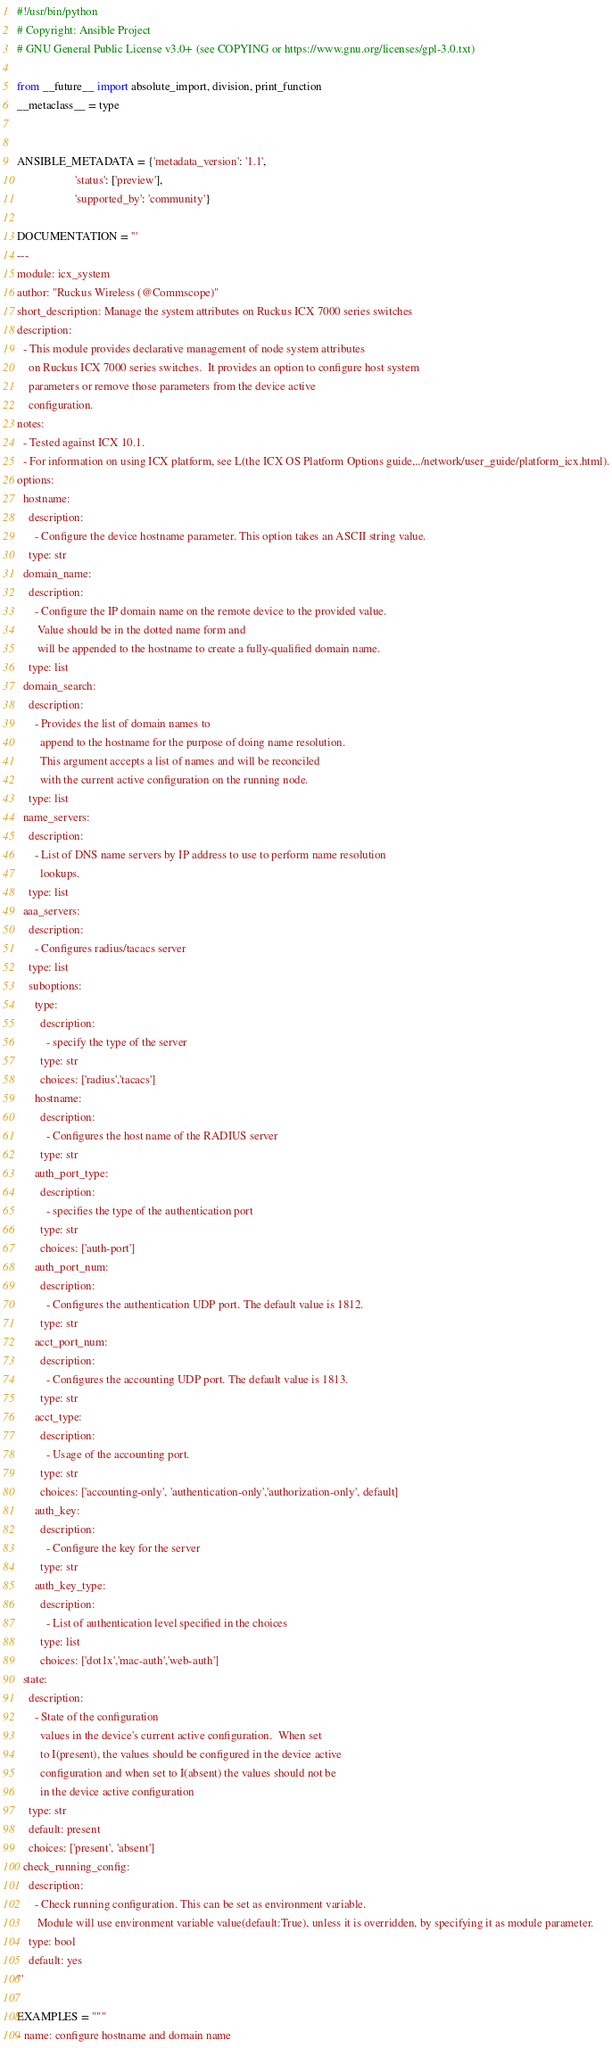Convert code to text. <code><loc_0><loc_0><loc_500><loc_500><_Python_>#!/usr/bin/python
# Copyright: Ansible Project
# GNU General Public License v3.0+ (see COPYING or https://www.gnu.org/licenses/gpl-3.0.txt)

from __future__ import absolute_import, division, print_function
__metaclass__ = type


ANSIBLE_METADATA = {'metadata_version': '1.1',
                    'status': ['preview'],
                    'supported_by': 'community'}

DOCUMENTATION = '''
---
module: icx_system
author: "Ruckus Wireless (@Commscope)"
short_description: Manage the system attributes on Ruckus ICX 7000 series switches
description:
  - This module provides declarative management of node system attributes
    on Ruckus ICX 7000 series switches.  It provides an option to configure host system
    parameters or remove those parameters from the device active
    configuration.
notes:
  - Tested against ICX 10.1.
  - For information on using ICX platform, see L(the ICX OS Platform Options guide,../network/user_guide/platform_icx.html).
options:
  hostname:
    description:
      - Configure the device hostname parameter. This option takes an ASCII string value.
    type: str
  domain_name:
    description:
      - Configure the IP domain name on the remote device to the provided value.
       Value should be in the dotted name form and
       will be appended to the hostname to create a fully-qualified domain name.
    type: list
  domain_search:
    description:
      - Provides the list of domain names to
        append to the hostname for the purpose of doing name resolution.
        This argument accepts a list of names and will be reconciled
        with the current active configuration on the running node.
    type: list
  name_servers:
    description:
      - List of DNS name servers by IP address to use to perform name resolution
        lookups.
    type: list
  aaa_servers:
    description:
      - Configures radius/tacacs server
    type: list
    suboptions:
      type:
        description:
          - specify the type of the server
        type: str
        choices: ['radius','tacacs']
      hostname:
        description:
          - Configures the host name of the RADIUS server
        type: str
      auth_port_type:
        description:
          - specifies the type of the authentication port
        type: str
        choices: ['auth-port']
      auth_port_num:
        description:
          - Configures the authentication UDP port. The default value is 1812.
        type: str
      acct_port_num:
        description:
          - Configures the accounting UDP port. The default value is 1813.
        type: str
      acct_type:
        description:
          - Usage of the accounting port.
        type: str
        choices: ['accounting-only', 'authentication-only','authorization-only', default]
      auth_key:
        description:
          - Configure the key for the server
        type: str
      auth_key_type:
        description:
          - List of authentication level specified in the choices
        type: list
        choices: ['dot1x','mac-auth','web-auth']
  state:
    description:
      - State of the configuration
        values in the device's current active configuration.  When set
        to I(present), the values should be configured in the device active
        configuration and when set to I(absent) the values should not be
        in the device active configuration
    type: str
    default: present
    choices: ['present', 'absent']
  check_running_config:
    description:
      - Check running configuration. This can be set as environment variable.
       Module will use environment variable value(default:True), unless it is overridden, by specifying it as module parameter.
    type: bool
    default: yes
'''

EXAMPLES = """
- name: configure hostname and domain name</code> 